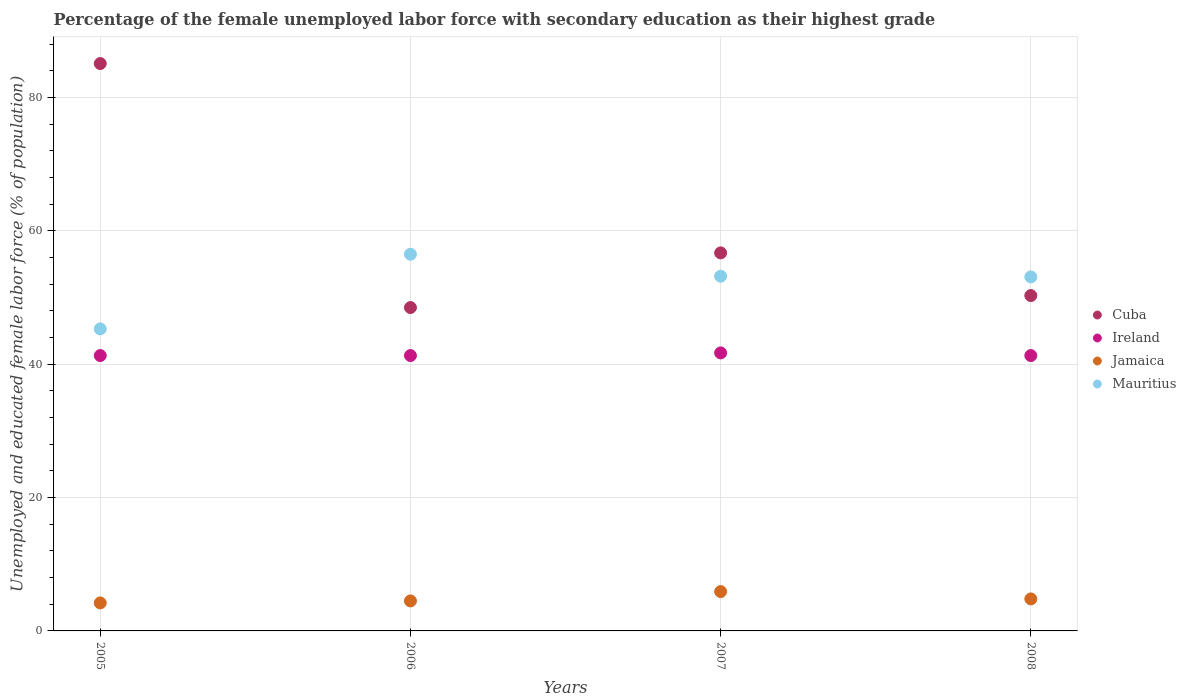How many different coloured dotlines are there?
Make the answer very short. 4. Is the number of dotlines equal to the number of legend labels?
Make the answer very short. Yes. What is the percentage of the unemployed female labor force with secondary education in Jamaica in 2005?
Your answer should be compact. 4.2. Across all years, what is the maximum percentage of the unemployed female labor force with secondary education in Cuba?
Offer a very short reply. 85.1. Across all years, what is the minimum percentage of the unemployed female labor force with secondary education in Jamaica?
Your answer should be compact. 4.2. In which year was the percentage of the unemployed female labor force with secondary education in Jamaica minimum?
Your answer should be very brief. 2005. What is the total percentage of the unemployed female labor force with secondary education in Mauritius in the graph?
Make the answer very short. 208.1. What is the difference between the percentage of the unemployed female labor force with secondary education in Mauritius in 2007 and that in 2008?
Offer a very short reply. 0.1. What is the difference between the percentage of the unemployed female labor force with secondary education in Mauritius in 2006 and the percentage of the unemployed female labor force with secondary education in Ireland in 2005?
Offer a very short reply. 15.2. What is the average percentage of the unemployed female labor force with secondary education in Ireland per year?
Keep it short and to the point. 41.4. In the year 2005, what is the difference between the percentage of the unemployed female labor force with secondary education in Ireland and percentage of the unemployed female labor force with secondary education in Cuba?
Keep it short and to the point. -43.8. In how many years, is the percentage of the unemployed female labor force with secondary education in Ireland greater than 4 %?
Provide a succinct answer. 4. What is the ratio of the percentage of the unemployed female labor force with secondary education in Mauritius in 2007 to that in 2008?
Your answer should be compact. 1. Is the percentage of the unemployed female labor force with secondary education in Mauritius in 2005 less than that in 2007?
Give a very brief answer. Yes. Is the difference between the percentage of the unemployed female labor force with secondary education in Ireland in 2006 and 2008 greater than the difference between the percentage of the unemployed female labor force with secondary education in Cuba in 2006 and 2008?
Make the answer very short. Yes. What is the difference between the highest and the second highest percentage of the unemployed female labor force with secondary education in Ireland?
Keep it short and to the point. 0.4. What is the difference between the highest and the lowest percentage of the unemployed female labor force with secondary education in Ireland?
Ensure brevity in your answer.  0.4. In how many years, is the percentage of the unemployed female labor force with secondary education in Mauritius greater than the average percentage of the unemployed female labor force with secondary education in Mauritius taken over all years?
Provide a short and direct response. 3. Is it the case that in every year, the sum of the percentage of the unemployed female labor force with secondary education in Jamaica and percentage of the unemployed female labor force with secondary education in Ireland  is greater than the sum of percentage of the unemployed female labor force with secondary education in Cuba and percentage of the unemployed female labor force with secondary education in Mauritius?
Give a very brief answer. No. How many dotlines are there?
Provide a succinct answer. 4. How many years are there in the graph?
Your response must be concise. 4. Where does the legend appear in the graph?
Offer a terse response. Center right. How many legend labels are there?
Offer a very short reply. 4. What is the title of the graph?
Provide a short and direct response. Percentage of the female unemployed labor force with secondary education as their highest grade. Does "Aruba" appear as one of the legend labels in the graph?
Ensure brevity in your answer.  No. What is the label or title of the Y-axis?
Make the answer very short. Unemployed and educated female labor force (% of population). What is the Unemployed and educated female labor force (% of population) of Cuba in 2005?
Provide a succinct answer. 85.1. What is the Unemployed and educated female labor force (% of population) in Ireland in 2005?
Keep it short and to the point. 41.3. What is the Unemployed and educated female labor force (% of population) in Jamaica in 2005?
Ensure brevity in your answer.  4.2. What is the Unemployed and educated female labor force (% of population) of Mauritius in 2005?
Offer a terse response. 45.3. What is the Unemployed and educated female labor force (% of population) of Cuba in 2006?
Keep it short and to the point. 48.5. What is the Unemployed and educated female labor force (% of population) in Ireland in 2006?
Provide a short and direct response. 41.3. What is the Unemployed and educated female labor force (% of population) of Mauritius in 2006?
Offer a terse response. 56.5. What is the Unemployed and educated female labor force (% of population) in Cuba in 2007?
Offer a very short reply. 56.7. What is the Unemployed and educated female labor force (% of population) of Ireland in 2007?
Make the answer very short. 41.7. What is the Unemployed and educated female labor force (% of population) of Jamaica in 2007?
Keep it short and to the point. 5.9. What is the Unemployed and educated female labor force (% of population) in Mauritius in 2007?
Offer a very short reply. 53.2. What is the Unemployed and educated female labor force (% of population) of Cuba in 2008?
Your answer should be compact. 50.3. What is the Unemployed and educated female labor force (% of population) of Ireland in 2008?
Make the answer very short. 41.3. What is the Unemployed and educated female labor force (% of population) of Jamaica in 2008?
Offer a very short reply. 4.8. What is the Unemployed and educated female labor force (% of population) of Mauritius in 2008?
Your answer should be compact. 53.1. Across all years, what is the maximum Unemployed and educated female labor force (% of population) in Cuba?
Offer a very short reply. 85.1. Across all years, what is the maximum Unemployed and educated female labor force (% of population) of Ireland?
Provide a short and direct response. 41.7. Across all years, what is the maximum Unemployed and educated female labor force (% of population) of Jamaica?
Offer a very short reply. 5.9. Across all years, what is the maximum Unemployed and educated female labor force (% of population) in Mauritius?
Offer a very short reply. 56.5. Across all years, what is the minimum Unemployed and educated female labor force (% of population) in Cuba?
Ensure brevity in your answer.  48.5. Across all years, what is the minimum Unemployed and educated female labor force (% of population) of Ireland?
Give a very brief answer. 41.3. Across all years, what is the minimum Unemployed and educated female labor force (% of population) of Jamaica?
Offer a terse response. 4.2. Across all years, what is the minimum Unemployed and educated female labor force (% of population) in Mauritius?
Provide a short and direct response. 45.3. What is the total Unemployed and educated female labor force (% of population) in Cuba in the graph?
Provide a short and direct response. 240.6. What is the total Unemployed and educated female labor force (% of population) of Ireland in the graph?
Ensure brevity in your answer.  165.6. What is the total Unemployed and educated female labor force (% of population) in Mauritius in the graph?
Give a very brief answer. 208.1. What is the difference between the Unemployed and educated female labor force (% of population) in Cuba in 2005 and that in 2006?
Your answer should be very brief. 36.6. What is the difference between the Unemployed and educated female labor force (% of population) of Cuba in 2005 and that in 2007?
Ensure brevity in your answer.  28.4. What is the difference between the Unemployed and educated female labor force (% of population) of Ireland in 2005 and that in 2007?
Your response must be concise. -0.4. What is the difference between the Unemployed and educated female labor force (% of population) of Cuba in 2005 and that in 2008?
Provide a short and direct response. 34.8. What is the difference between the Unemployed and educated female labor force (% of population) of Jamaica in 2005 and that in 2008?
Your answer should be very brief. -0.6. What is the difference between the Unemployed and educated female labor force (% of population) of Mauritius in 2005 and that in 2008?
Give a very brief answer. -7.8. What is the difference between the Unemployed and educated female labor force (% of population) in Ireland in 2006 and that in 2007?
Offer a very short reply. -0.4. What is the difference between the Unemployed and educated female labor force (% of population) of Jamaica in 2006 and that in 2007?
Your response must be concise. -1.4. What is the difference between the Unemployed and educated female labor force (% of population) in Cuba in 2006 and that in 2008?
Keep it short and to the point. -1.8. What is the difference between the Unemployed and educated female labor force (% of population) in Ireland in 2006 and that in 2008?
Provide a short and direct response. 0. What is the difference between the Unemployed and educated female labor force (% of population) of Cuba in 2007 and that in 2008?
Your answer should be very brief. 6.4. What is the difference between the Unemployed and educated female labor force (% of population) of Mauritius in 2007 and that in 2008?
Make the answer very short. 0.1. What is the difference between the Unemployed and educated female labor force (% of population) of Cuba in 2005 and the Unemployed and educated female labor force (% of population) of Ireland in 2006?
Ensure brevity in your answer.  43.8. What is the difference between the Unemployed and educated female labor force (% of population) in Cuba in 2005 and the Unemployed and educated female labor force (% of population) in Jamaica in 2006?
Offer a terse response. 80.6. What is the difference between the Unemployed and educated female labor force (% of population) in Cuba in 2005 and the Unemployed and educated female labor force (% of population) in Mauritius in 2006?
Make the answer very short. 28.6. What is the difference between the Unemployed and educated female labor force (% of population) of Ireland in 2005 and the Unemployed and educated female labor force (% of population) of Jamaica in 2006?
Ensure brevity in your answer.  36.8. What is the difference between the Unemployed and educated female labor force (% of population) in Ireland in 2005 and the Unemployed and educated female labor force (% of population) in Mauritius in 2006?
Your answer should be very brief. -15.2. What is the difference between the Unemployed and educated female labor force (% of population) of Jamaica in 2005 and the Unemployed and educated female labor force (% of population) of Mauritius in 2006?
Provide a succinct answer. -52.3. What is the difference between the Unemployed and educated female labor force (% of population) in Cuba in 2005 and the Unemployed and educated female labor force (% of population) in Ireland in 2007?
Provide a short and direct response. 43.4. What is the difference between the Unemployed and educated female labor force (% of population) in Cuba in 2005 and the Unemployed and educated female labor force (% of population) in Jamaica in 2007?
Offer a terse response. 79.2. What is the difference between the Unemployed and educated female labor force (% of population) of Cuba in 2005 and the Unemployed and educated female labor force (% of population) of Mauritius in 2007?
Provide a short and direct response. 31.9. What is the difference between the Unemployed and educated female labor force (% of population) in Ireland in 2005 and the Unemployed and educated female labor force (% of population) in Jamaica in 2007?
Provide a short and direct response. 35.4. What is the difference between the Unemployed and educated female labor force (% of population) in Jamaica in 2005 and the Unemployed and educated female labor force (% of population) in Mauritius in 2007?
Ensure brevity in your answer.  -49. What is the difference between the Unemployed and educated female labor force (% of population) of Cuba in 2005 and the Unemployed and educated female labor force (% of population) of Ireland in 2008?
Ensure brevity in your answer.  43.8. What is the difference between the Unemployed and educated female labor force (% of population) in Cuba in 2005 and the Unemployed and educated female labor force (% of population) in Jamaica in 2008?
Your response must be concise. 80.3. What is the difference between the Unemployed and educated female labor force (% of population) in Cuba in 2005 and the Unemployed and educated female labor force (% of population) in Mauritius in 2008?
Ensure brevity in your answer.  32. What is the difference between the Unemployed and educated female labor force (% of population) of Ireland in 2005 and the Unemployed and educated female labor force (% of population) of Jamaica in 2008?
Keep it short and to the point. 36.5. What is the difference between the Unemployed and educated female labor force (% of population) of Jamaica in 2005 and the Unemployed and educated female labor force (% of population) of Mauritius in 2008?
Offer a terse response. -48.9. What is the difference between the Unemployed and educated female labor force (% of population) of Cuba in 2006 and the Unemployed and educated female labor force (% of population) of Ireland in 2007?
Give a very brief answer. 6.8. What is the difference between the Unemployed and educated female labor force (% of population) of Cuba in 2006 and the Unemployed and educated female labor force (% of population) of Jamaica in 2007?
Ensure brevity in your answer.  42.6. What is the difference between the Unemployed and educated female labor force (% of population) in Ireland in 2006 and the Unemployed and educated female labor force (% of population) in Jamaica in 2007?
Provide a short and direct response. 35.4. What is the difference between the Unemployed and educated female labor force (% of population) in Jamaica in 2006 and the Unemployed and educated female labor force (% of population) in Mauritius in 2007?
Provide a short and direct response. -48.7. What is the difference between the Unemployed and educated female labor force (% of population) in Cuba in 2006 and the Unemployed and educated female labor force (% of population) in Ireland in 2008?
Ensure brevity in your answer.  7.2. What is the difference between the Unemployed and educated female labor force (% of population) in Cuba in 2006 and the Unemployed and educated female labor force (% of population) in Jamaica in 2008?
Provide a succinct answer. 43.7. What is the difference between the Unemployed and educated female labor force (% of population) in Ireland in 2006 and the Unemployed and educated female labor force (% of population) in Jamaica in 2008?
Offer a very short reply. 36.5. What is the difference between the Unemployed and educated female labor force (% of population) in Ireland in 2006 and the Unemployed and educated female labor force (% of population) in Mauritius in 2008?
Make the answer very short. -11.8. What is the difference between the Unemployed and educated female labor force (% of population) of Jamaica in 2006 and the Unemployed and educated female labor force (% of population) of Mauritius in 2008?
Make the answer very short. -48.6. What is the difference between the Unemployed and educated female labor force (% of population) in Cuba in 2007 and the Unemployed and educated female labor force (% of population) in Ireland in 2008?
Give a very brief answer. 15.4. What is the difference between the Unemployed and educated female labor force (% of population) in Cuba in 2007 and the Unemployed and educated female labor force (% of population) in Jamaica in 2008?
Your answer should be compact. 51.9. What is the difference between the Unemployed and educated female labor force (% of population) of Ireland in 2007 and the Unemployed and educated female labor force (% of population) of Jamaica in 2008?
Provide a succinct answer. 36.9. What is the difference between the Unemployed and educated female labor force (% of population) in Jamaica in 2007 and the Unemployed and educated female labor force (% of population) in Mauritius in 2008?
Offer a terse response. -47.2. What is the average Unemployed and educated female labor force (% of population) of Cuba per year?
Make the answer very short. 60.15. What is the average Unemployed and educated female labor force (% of population) in Ireland per year?
Your answer should be very brief. 41.4. What is the average Unemployed and educated female labor force (% of population) in Jamaica per year?
Give a very brief answer. 4.85. What is the average Unemployed and educated female labor force (% of population) in Mauritius per year?
Your answer should be compact. 52.02. In the year 2005, what is the difference between the Unemployed and educated female labor force (% of population) of Cuba and Unemployed and educated female labor force (% of population) of Ireland?
Ensure brevity in your answer.  43.8. In the year 2005, what is the difference between the Unemployed and educated female labor force (% of population) of Cuba and Unemployed and educated female labor force (% of population) of Jamaica?
Ensure brevity in your answer.  80.9. In the year 2005, what is the difference between the Unemployed and educated female labor force (% of population) in Cuba and Unemployed and educated female labor force (% of population) in Mauritius?
Ensure brevity in your answer.  39.8. In the year 2005, what is the difference between the Unemployed and educated female labor force (% of population) in Ireland and Unemployed and educated female labor force (% of population) in Jamaica?
Provide a succinct answer. 37.1. In the year 2005, what is the difference between the Unemployed and educated female labor force (% of population) of Jamaica and Unemployed and educated female labor force (% of population) of Mauritius?
Offer a very short reply. -41.1. In the year 2006, what is the difference between the Unemployed and educated female labor force (% of population) of Cuba and Unemployed and educated female labor force (% of population) of Mauritius?
Your answer should be compact. -8. In the year 2006, what is the difference between the Unemployed and educated female labor force (% of population) of Ireland and Unemployed and educated female labor force (% of population) of Jamaica?
Offer a terse response. 36.8. In the year 2006, what is the difference between the Unemployed and educated female labor force (% of population) of Ireland and Unemployed and educated female labor force (% of population) of Mauritius?
Give a very brief answer. -15.2. In the year 2006, what is the difference between the Unemployed and educated female labor force (% of population) in Jamaica and Unemployed and educated female labor force (% of population) in Mauritius?
Provide a short and direct response. -52. In the year 2007, what is the difference between the Unemployed and educated female labor force (% of population) of Cuba and Unemployed and educated female labor force (% of population) of Jamaica?
Your answer should be very brief. 50.8. In the year 2007, what is the difference between the Unemployed and educated female labor force (% of population) in Ireland and Unemployed and educated female labor force (% of population) in Jamaica?
Give a very brief answer. 35.8. In the year 2007, what is the difference between the Unemployed and educated female labor force (% of population) of Ireland and Unemployed and educated female labor force (% of population) of Mauritius?
Give a very brief answer. -11.5. In the year 2007, what is the difference between the Unemployed and educated female labor force (% of population) of Jamaica and Unemployed and educated female labor force (% of population) of Mauritius?
Your answer should be compact. -47.3. In the year 2008, what is the difference between the Unemployed and educated female labor force (% of population) of Cuba and Unemployed and educated female labor force (% of population) of Ireland?
Keep it short and to the point. 9. In the year 2008, what is the difference between the Unemployed and educated female labor force (% of population) of Cuba and Unemployed and educated female labor force (% of population) of Jamaica?
Offer a very short reply. 45.5. In the year 2008, what is the difference between the Unemployed and educated female labor force (% of population) of Cuba and Unemployed and educated female labor force (% of population) of Mauritius?
Offer a terse response. -2.8. In the year 2008, what is the difference between the Unemployed and educated female labor force (% of population) in Ireland and Unemployed and educated female labor force (% of population) in Jamaica?
Your response must be concise. 36.5. In the year 2008, what is the difference between the Unemployed and educated female labor force (% of population) in Jamaica and Unemployed and educated female labor force (% of population) in Mauritius?
Your answer should be compact. -48.3. What is the ratio of the Unemployed and educated female labor force (% of population) of Cuba in 2005 to that in 2006?
Provide a succinct answer. 1.75. What is the ratio of the Unemployed and educated female labor force (% of population) of Ireland in 2005 to that in 2006?
Ensure brevity in your answer.  1. What is the ratio of the Unemployed and educated female labor force (% of population) in Mauritius in 2005 to that in 2006?
Keep it short and to the point. 0.8. What is the ratio of the Unemployed and educated female labor force (% of population) of Cuba in 2005 to that in 2007?
Provide a succinct answer. 1.5. What is the ratio of the Unemployed and educated female labor force (% of population) of Ireland in 2005 to that in 2007?
Offer a terse response. 0.99. What is the ratio of the Unemployed and educated female labor force (% of population) of Jamaica in 2005 to that in 2007?
Make the answer very short. 0.71. What is the ratio of the Unemployed and educated female labor force (% of population) in Mauritius in 2005 to that in 2007?
Your response must be concise. 0.85. What is the ratio of the Unemployed and educated female labor force (% of population) of Cuba in 2005 to that in 2008?
Your answer should be very brief. 1.69. What is the ratio of the Unemployed and educated female labor force (% of population) in Mauritius in 2005 to that in 2008?
Keep it short and to the point. 0.85. What is the ratio of the Unemployed and educated female labor force (% of population) in Cuba in 2006 to that in 2007?
Your response must be concise. 0.86. What is the ratio of the Unemployed and educated female labor force (% of population) of Jamaica in 2006 to that in 2007?
Offer a very short reply. 0.76. What is the ratio of the Unemployed and educated female labor force (% of population) of Mauritius in 2006 to that in 2007?
Keep it short and to the point. 1.06. What is the ratio of the Unemployed and educated female labor force (% of population) in Cuba in 2006 to that in 2008?
Your response must be concise. 0.96. What is the ratio of the Unemployed and educated female labor force (% of population) of Jamaica in 2006 to that in 2008?
Offer a very short reply. 0.94. What is the ratio of the Unemployed and educated female labor force (% of population) of Mauritius in 2006 to that in 2008?
Your answer should be compact. 1.06. What is the ratio of the Unemployed and educated female labor force (% of population) in Cuba in 2007 to that in 2008?
Provide a succinct answer. 1.13. What is the ratio of the Unemployed and educated female labor force (% of population) in Ireland in 2007 to that in 2008?
Your answer should be very brief. 1.01. What is the ratio of the Unemployed and educated female labor force (% of population) in Jamaica in 2007 to that in 2008?
Ensure brevity in your answer.  1.23. What is the ratio of the Unemployed and educated female labor force (% of population) of Mauritius in 2007 to that in 2008?
Offer a terse response. 1. What is the difference between the highest and the second highest Unemployed and educated female labor force (% of population) in Cuba?
Make the answer very short. 28.4. What is the difference between the highest and the second highest Unemployed and educated female labor force (% of population) in Ireland?
Your answer should be compact. 0.4. What is the difference between the highest and the second highest Unemployed and educated female labor force (% of population) of Jamaica?
Your answer should be compact. 1.1. What is the difference between the highest and the lowest Unemployed and educated female labor force (% of population) of Cuba?
Give a very brief answer. 36.6. What is the difference between the highest and the lowest Unemployed and educated female labor force (% of population) in Jamaica?
Make the answer very short. 1.7. What is the difference between the highest and the lowest Unemployed and educated female labor force (% of population) of Mauritius?
Provide a succinct answer. 11.2. 